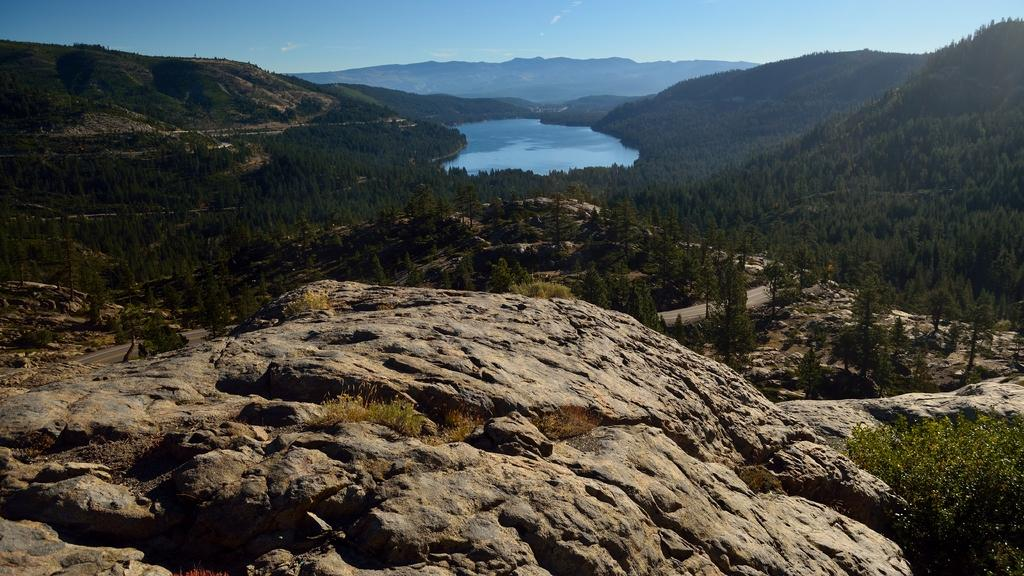What type of landscape is depicted in the image? The image features hills and trees. Is there any water visible in the image? Yes, there is water visible in the image. What can be seen in the background of the image? The sky is visible in the background of the image. What type of religious punishment is being depicted in the image? There is no religious punishment depicted in the image; it features hills, trees, water, and the sky. Can you tell me which character from the story is wearing a locket in the image? There are no characters or stories mentioned in the image; it is a landscape scene with hills, trees, water, and the sky. 